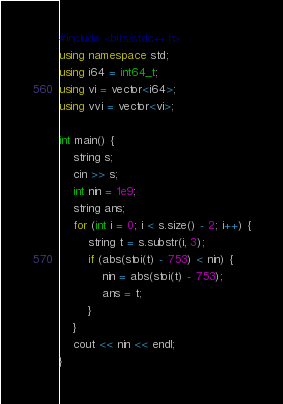<code> <loc_0><loc_0><loc_500><loc_500><_C++_>#include <bits/stdc++.h>
using namespace std;
using i64 = int64_t;
using vi = vector<i64>;
using vvi = vector<vi>;

int main() {
    string s;
    cin >> s;
    int nin = 1e9;
    string ans;
    for (int i = 0; i < s.size() - 2; i++) {
        string t = s.substr(i, 3);
        if (abs(stoi(t) - 753) < nin) {
            nin = abs(stoi(t) - 753);
            ans = t;
        }
    }
    cout << nin << endl;
}</code> 